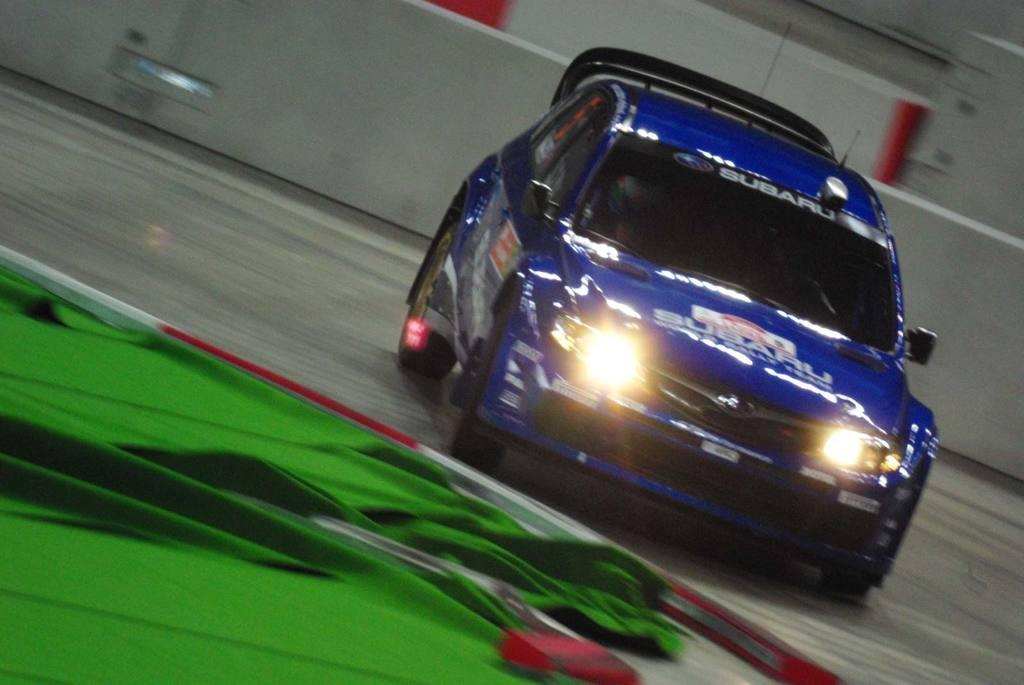What type of vehicle is in the image? There is a blue car in the image. Is there any text on the car? Yes, the car has some text on it. What can be seen in the background of the image? There is a wall visible in the image. What type of location does the image appear to depict? The image appears to be an inner view of a building. How does the car's nerve system function in the image? Cars do not have a nerve system; they are mechanical devices powered by engines. 